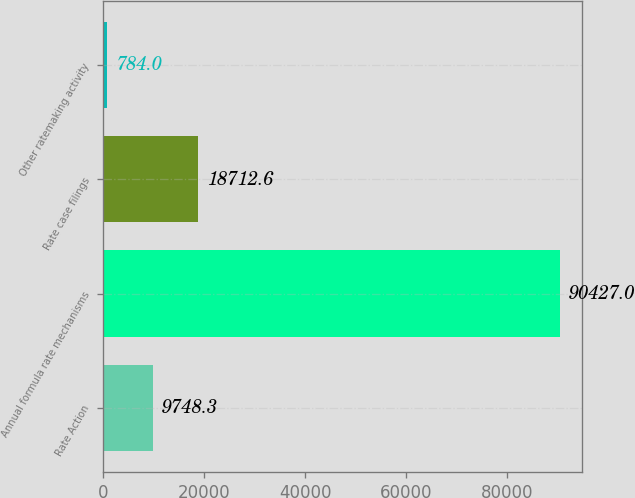Convert chart to OTSL. <chart><loc_0><loc_0><loc_500><loc_500><bar_chart><fcel>Rate Action<fcel>Annual formula rate mechanisms<fcel>Rate case filings<fcel>Other ratemaking activity<nl><fcel>9748.3<fcel>90427<fcel>18712.6<fcel>784<nl></chart> 